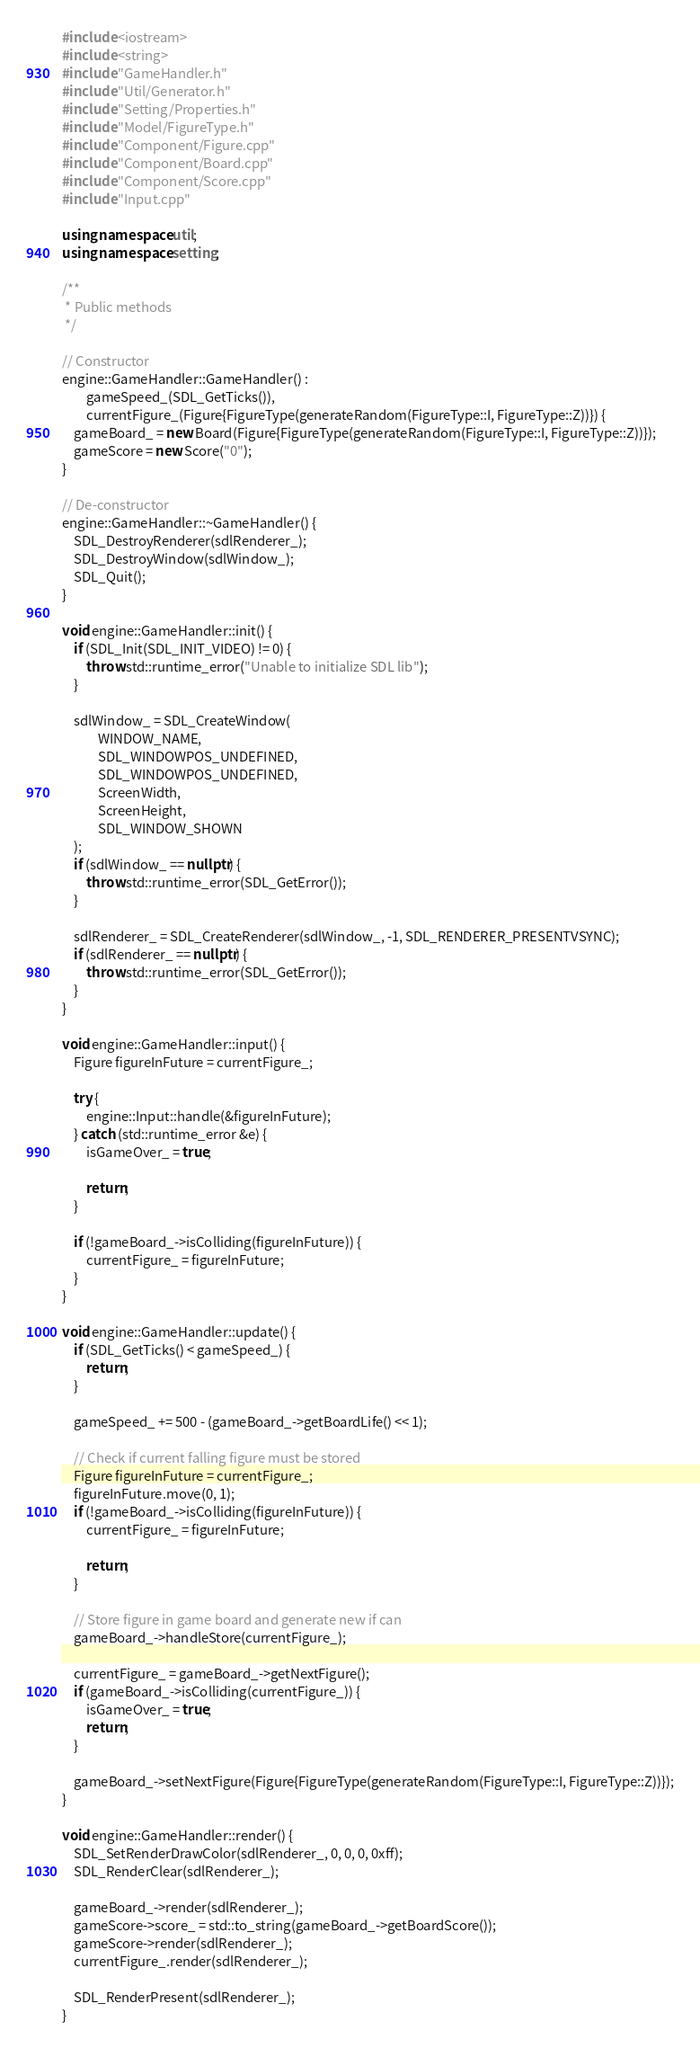<code> <loc_0><loc_0><loc_500><loc_500><_C++_>#include <iostream>
#include <string>
#include "GameHandler.h"
#include "Util/Generator.h"
#include "Setting/Properties.h"
#include "Model/FigureType.h"
#include "Component/Figure.cpp"
#include "Component/Board.cpp"
#include "Component/Score.cpp"
#include "Input.cpp"

using namespace util;
using namespace setting;

/**
 * Public methods
 */

// Constructor
engine::GameHandler::GameHandler() :
        gameSpeed_(SDL_GetTicks()),
        currentFigure_(Figure{FigureType(generateRandom(FigureType::I, FigureType::Z))}) {
    gameBoard_ = new Board(Figure{FigureType(generateRandom(FigureType::I, FigureType::Z))});
    gameScore = new Score("0");
}

// De-constructor
engine::GameHandler::~GameHandler() {
    SDL_DestroyRenderer(sdlRenderer_);
    SDL_DestroyWindow(sdlWindow_);
    SDL_Quit();
}

void engine::GameHandler::init() {
    if (SDL_Init(SDL_INIT_VIDEO) != 0) {
        throw std::runtime_error("Unable to initialize SDL lib");
    }

    sdlWindow_ = SDL_CreateWindow(
            WINDOW_NAME,
            SDL_WINDOWPOS_UNDEFINED,
            SDL_WINDOWPOS_UNDEFINED,
            ScreenWidth,
            ScreenHeight,
            SDL_WINDOW_SHOWN
    );
    if (sdlWindow_ == nullptr) {
        throw std::runtime_error(SDL_GetError());
    }

    sdlRenderer_ = SDL_CreateRenderer(sdlWindow_, -1, SDL_RENDERER_PRESENTVSYNC);
    if (sdlRenderer_ == nullptr) {
        throw std::runtime_error(SDL_GetError());
    }
}

void engine::GameHandler::input() {
    Figure figureInFuture = currentFigure_;

    try {
        engine::Input::handle(&figureInFuture);
    } catch (std::runtime_error &e) {
        isGameOver_ = true;

        return;
    }

    if (!gameBoard_->isColliding(figureInFuture)) {
        currentFigure_ = figureInFuture;
    }
}

void engine::GameHandler::update() {
    if (SDL_GetTicks() < gameSpeed_) {
        return;
    }

    gameSpeed_ += 500 - (gameBoard_->getBoardLife() << 1);

    // Check if current falling figure must be stored
    Figure figureInFuture = currentFigure_;
    figureInFuture.move(0, 1);
    if (!gameBoard_->isColliding(figureInFuture)) {
        currentFigure_ = figureInFuture;

        return;
    }

    // Store figure in game board and generate new if can
    gameBoard_->handleStore(currentFigure_);

    currentFigure_ = gameBoard_->getNextFigure();
    if (gameBoard_->isColliding(currentFigure_)) {
        isGameOver_ = true;
        return;
    }

    gameBoard_->setNextFigure(Figure{FigureType(generateRandom(FigureType::I, FigureType::Z))});
}

void engine::GameHandler::render() {
    SDL_SetRenderDrawColor(sdlRenderer_, 0, 0, 0, 0xff);
    SDL_RenderClear(sdlRenderer_);

    gameBoard_->render(sdlRenderer_);
    gameScore->score_ = std::to_string(gameBoard_->getBoardScore());
    gameScore->render(sdlRenderer_);
    currentFigure_.render(sdlRenderer_);

    SDL_RenderPresent(sdlRenderer_);
}
</code> 